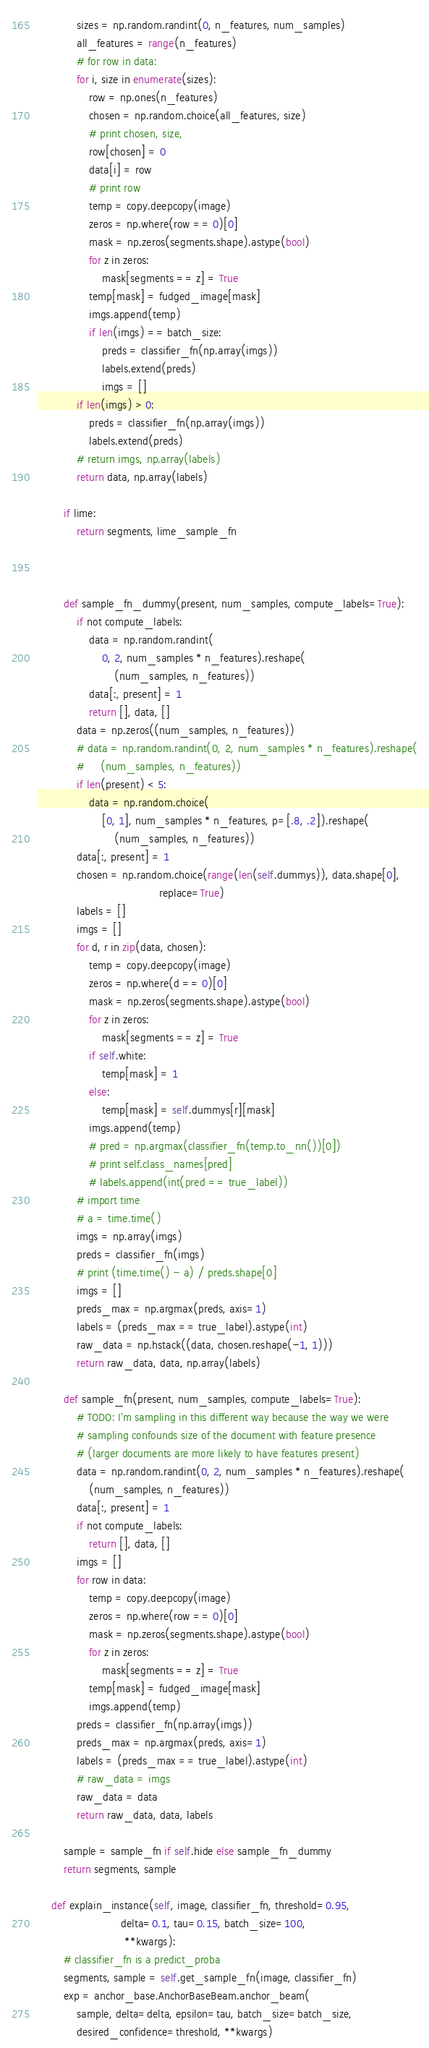Convert code to text. <code><loc_0><loc_0><loc_500><loc_500><_Python_>            sizes = np.random.randint(0, n_features, num_samples)
            all_features = range(n_features)
            # for row in data:
            for i, size in enumerate(sizes):
                row = np.ones(n_features)
                chosen = np.random.choice(all_features, size)
                # print chosen, size,
                row[chosen] = 0
                data[i] = row
                # print row
                temp = copy.deepcopy(image)
                zeros = np.where(row == 0)[0]
                mask = np.zeros(segments.shape).astype(bool)
                for z in zeros:
                    mask[segments == z] = True
                temp[mask] = fudged_image[mask]
                imgs.append(temp)
                if len(imgs) == batch_size:
                    preds = classifier_fn(np.array(imgs))
                    labels.extend(preds)
                    imgs = []
            if len(imgs) > 0:
                preds = classifier_fn(np.array(imgs))
                labels.extend(preds)
            # return imgs, np.array(labels)
            return data, np.array(labels)

        if lime:
            return segments, lime_sample_fn



        def sample_fn_dummy(present, num_samples, compute_labels=True):
            if not compute_labels:
                data = np.random.randint(
                    0, 2, num_samples * n_features).reshape(
                        (num_samples, n_features))
                data[:, present] = 1
                return [], data, []
            data = np.zeros((num_samples, n_features))
            # data = np.random.randint(0, 2, num_samples * n_features).reshape(
            #     (num_samples, n_features))
            if len(present) < 5:
                data = np.random.choice(
                    [0, 1], num_samples * n_features, p=[.8, .2]).reshape(
                        (num_samples, n_features))
            data[:, present] = 1
            chosen = np.random.choice(range(len(self.dummys)), data.shape[0],
                                      replace=True)
            labels = []
            imgs = []
            for d, r in zip(data, chosen):
                temp = copy.deepcopy(image)
                zeros = np.where(d == 0)[0]
                mask = np.zeros(segments.shape).astype(bool)
                for z in zeros:
                    mask[segments == z] = True
                if self.white:
                    temp[mask] = 1
                else:
                    temp[mask] = self.dummys[r][mask]
                imgs.append(temp)
                # pred = np.argmax(classifier_fn(temp.to_nn())[0])
                # print self.class_names[pred]
                # labels.append(int(pred == true_label))
            # import time
            # a = time.time()
            imgs = np.array(imgs)
            preds = classifier_fn(imgs)
            # print (time.time() - a) / preds.shape[0]
            imgs = []
            preds_max = np.argmax(preds, axis=1)
            labels = (preds_max == true_label).astype(int)
            raw_data = np.hstack((data, chosen.reshape(-1, 1)))
            return raw_data, data, np.array(labels)

        def sample_fn(present, num_samples, compute_labels=True):
            # TODO: I'm sampling in this different way because the way we were
            # sampling confounds size of the document with feature presence
            # (larger documents are more likely to have features present)
            data = np.random.randint(0, 2, num_samples * n_features).reshape(
                (num_samples, n_features))
            data[:, present] = 1
            if not compute_labels:
                return [], data, []
            imgs = []
            for row in data:
                temp = copy.deepcopy(image)
                zeros = np.where(row == 0)[0]
                mask = np.zeros(segments.shape).astype(bool)
                for z in zeros:
                    mask[segments == z] = True
                temp[mask] = fudged_image[mask]
                imgs.append(temp)
            preds = classifier_fn(np.array(imgs))
            preds_max = np.argmax(preds, axis=1)
            labels = (preds_max == true_label).astype(int)
            # raw_data = imgs
            raw_data = data
            return raw_data, data, labels

        sample = sample_fn if self.hide else sample_fn_dummy
        return segments, sample

    def explain_instance(self, image, classifier_fn, threshold=0.95,
                          delta=0.1, tau=0.15, batch_size=100,
                           **kwargs):
        # classifier_fn is a predict_proba
        segments, sample = self.get_sample_fn(image, classifier_fn)
        exp = anchor_base.AnchorBaseBeam.anchor_beam(
            sample, delta=delta, epsilon=tau, batch_size=batch_size,
            desired_confidence=threshold, **kwargs)</code> 